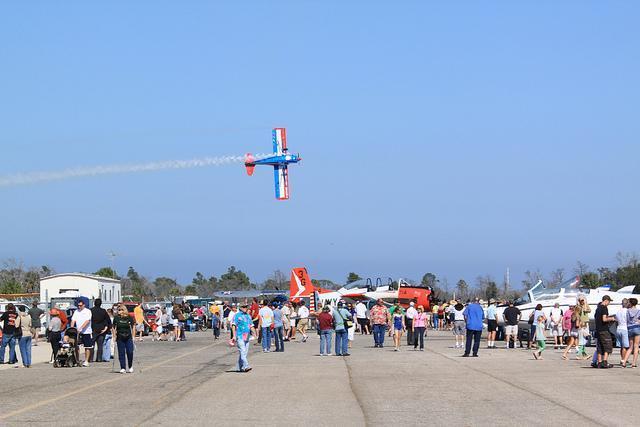How many planes are in the sky?
Give a very brief answer. 1. How many people can you see?
Give a very brief answer. 1. How many airplanes are there?
Give a very brief answer. 2. How many cars are in the background?
Give a very brief answer. 0. 